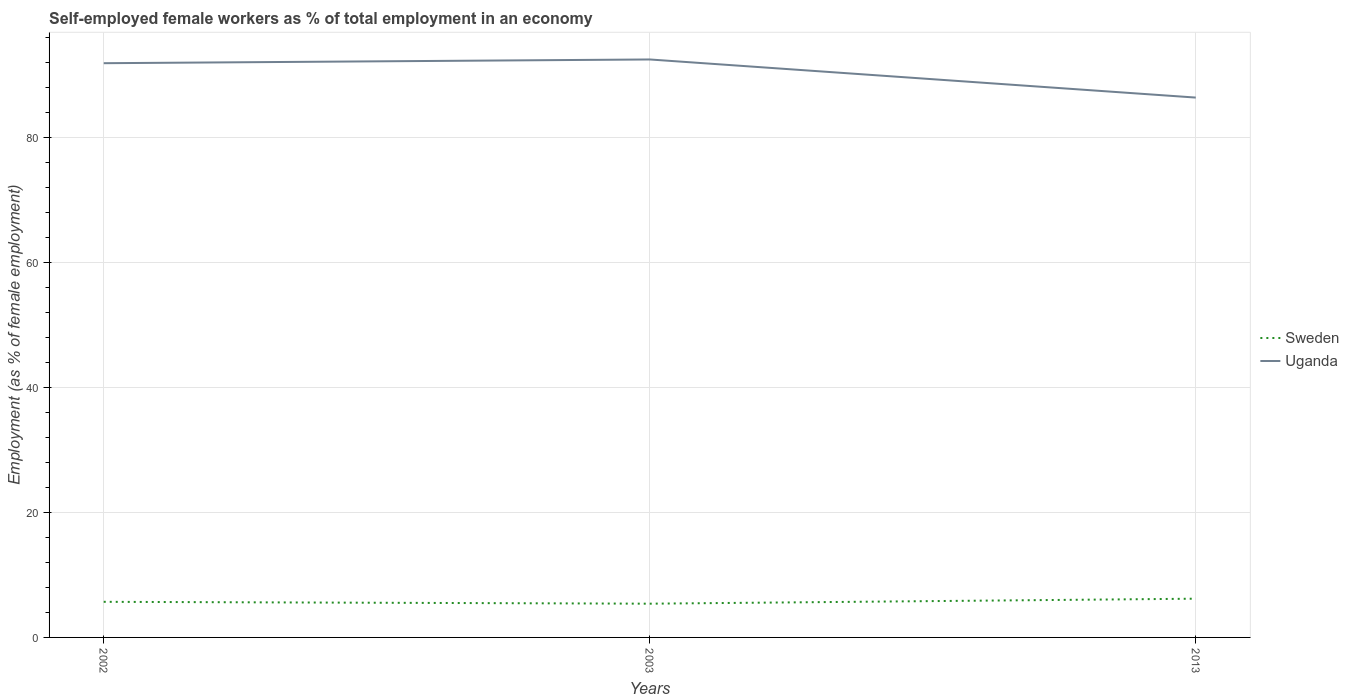Does the line corresponding to Uganda intersect with the line corresponding to Sweden?
Offer a very short reply. No. Is the number of lines equal to the number of legend labels?
Your answer should be compact. Yes. Across all years, what is the maximum percentage of self-employed female workers in Sweden?
Offer a very short reply. 5.4. In which year was the percentage of self-employed female workers in Uganda maximum?
Offer a very short reply. 2013. What is the total percentage of self-employed female workers in Sweden in the graph?
Provide a succinct answer. -0.8. What is the difference between the highest and the second highest percentage of self-employed female workers in Uganda?
Make the answer very short. 6.1. Is the percentage of self-employed female workers in Sweden strictly greater than the percentage of self-employed female workers in Uganda over the years?
Make the answer very short. Yes. How many lines are there?
Give a very brief answer. 2. Does the graph contain grids?
Offer a very short reply. Yes. How many legend labels are there?
Offer a very short reply. 2. How are the legend labels stacked?
Keep it short and to the point. Vertical. What is the title of the graph?
Offer a terse response. Self-employed female workers as % of total employment in an economy. What is the label or title of the Y-axis?
Provide a succinct answer. Employment (as % of female employment). What is the Employment (as % of female employment) of Sweden in 2002?
Give a very brief answer. 5.7. What is the Employment (as % of female employment) of Uganda in 2002?
Keep it short and to the point. 91.9. What is the Employment (as % of female employment) in Sweden in 2003?
Ensure brevity in your answer.  5.4. What is the Employment (as % of female employment) in Uganda in 2003?
Your answer should be compact. 92.5. What is the Employment (as % of female employment) in Sweden in 2013?
Provide a short and direct response. 6.2. What is the Employment (as % of female employment) in Uganda in 2013?
Provide a succinct answer. 86.4. Across all years, what is the maximum Employment (as % of female employment) of Sweden?
Give a very brief answer. 6.2. Across all years, what is the maximum Employment (as % of female employment) in Uganda?
Offer a terse response. 92.5. Across all years, what is the minimum Employment (as % of female employment) of Sweden?
Offer a terse response. 5.4. Across all years, what is the minimum Employment (as % of female employment) in Uganda?
Provide a succinct answer. 86.4. What is the total Employment (as % of female employment) of Sweden in the graph?
Offer a very short reply. 17.3. What is the total Employment (as % of female employment) in Uganda in the graph?
Your response must be concise. 270.8. What is the difference between the Employment (as % of female employment) in Uganda in 2002 and that in 2003?
Give a very brief answer. -0.6. What is the difference between the Employment (as % of female employment) of Uganda in 2002 and that in 2013?
Give a very brief answer. 5.5. What is the difference between the Employment (as % of female employment) in Sweden in 2003 and that in 2013?
Your response must be concise. -0.8. What is the difference between the Employment (as % of female employment) in Sweden in 2002 and the Employment (as % of female employment) in Uganda in 2003?
Ensure brevity in your answer.  -86.8. What is the difference between the Employment (as % of female employment) in Sweden in 2002 and the Employment (as % of female employment) in Uganda in 2013?
Your response must be concise. -80.7. What is the difference between the Employment (as % of female employment) in Sweden in 2003 and the Employment (as % of female employment) in Uganda in 2013?
Ensure brevity in your answer.  -81. What is the average Employment (as % of female employment) in Sweden per year?
Your response must be concise. 5.77. What is the average Employment (as % of female employment) in Uganda per year?
Offer a terse response. 90.27. In the year 2002, what is the difference between the Employment (as % of female employment) in Sweden and Employment (as % of female employment) in Uganda?
Provide a succinct answer. -86.2. In the year 2003, what is the difference between the Employment (as % of female employment) in Sweden and Employment (as % of female employment) in Uganda?
Provide a short and direct response. -87.1. In the year 2013, what is the difference between the Employment (as % of female employment) of Sweden and Employment (as % of female employment) of Uganda?
Offer a terse response. -80.2. What is the ratio of the Employment (as % of female employment) of Sweden in 2002 to that in 2003?
Make the answer very short. 1.06. What is the ratio of the Employment (as % of female employment) of Uganda in 2002 to that in 2003?
Offer a terse response. 0.99. What is the ratio of the Employment (as % of female employment) of Sweden in 2002 to that in 2013?
Your answer should be compact. 0.92. What is the ratio of the Employment (as % of female employment) in Uganda in 2002 to that in 2013?
Provide a succinct answer. 1.06. What is the ratio of the Employment (as % of female employment) in Sweden in 2003 to that in 2013?
Give a very brief answer. 0.87. What is the ratio of the Employment (as % of female employment) of Uganda in 2003 to that in 2013?
Your answer should be compact. 1.07. What is the difference between the highest and the second highest Employment (as % of female employment) in Sweden?
Offer a terse response. 0.5. What is the difference between the highest and the lowest Employment (as % of female employment) in Sweden?
Your response must be concise. 0.8. What is the difference between the highest and the lowest Employment (as % of female employment) of Uganda?
Give a very brief answer. 6.1. 